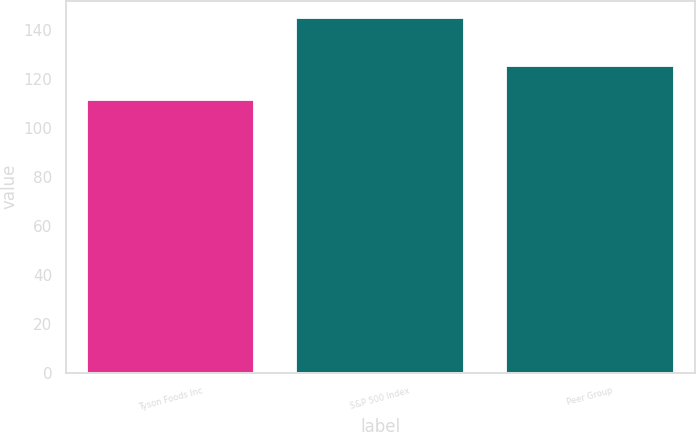Convert chart. <chart><loc_0><loc_0><loc_500><loc_500><bar_chart><fcel>Tyson Foods Inc<fcel>S&P 500 Index<fcel>Peer Group<nl><fcel>111.59<fcel>144.81<fcel>125.17<nl></chart> 